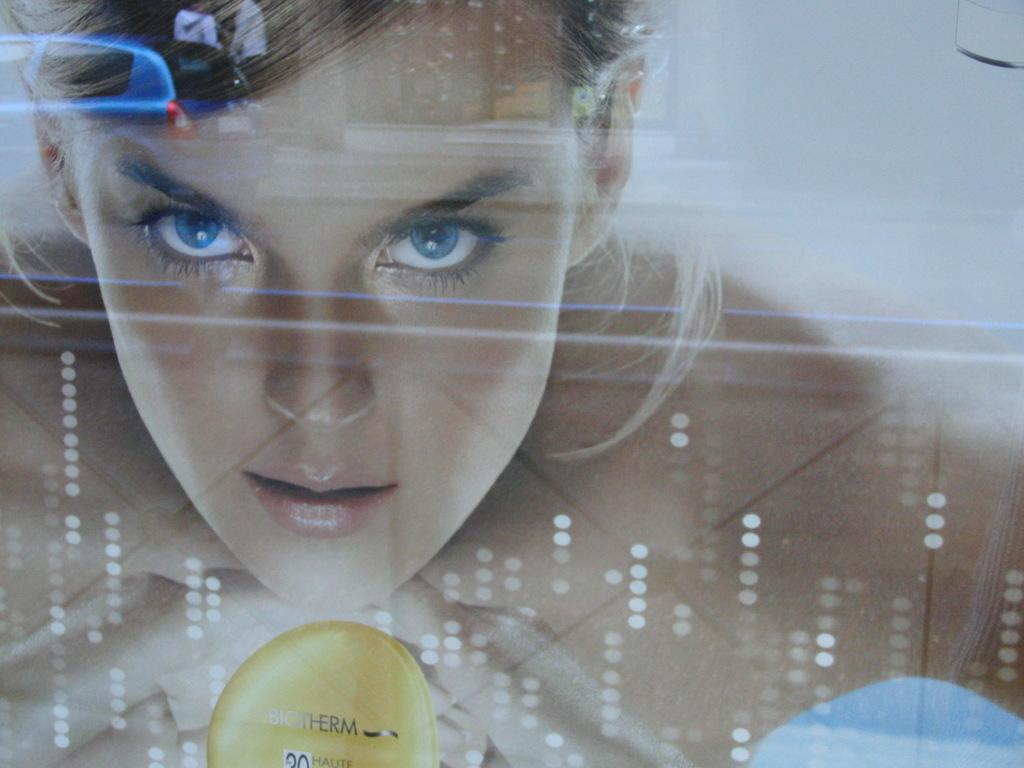What is the main object in the image? There is a screen in the image. What can be seen on the screen? A vehicle is visible on the screen, along with two persons standing behind the vehicle. How many people are visible on the screen? There is one person visible on the screen, in addition to the two persons standing behind the vehicle. Where is the toad located in the image? There is no toad present in the image. What type of knife is being used by the person on the screen? There is no knife visible in the image. 